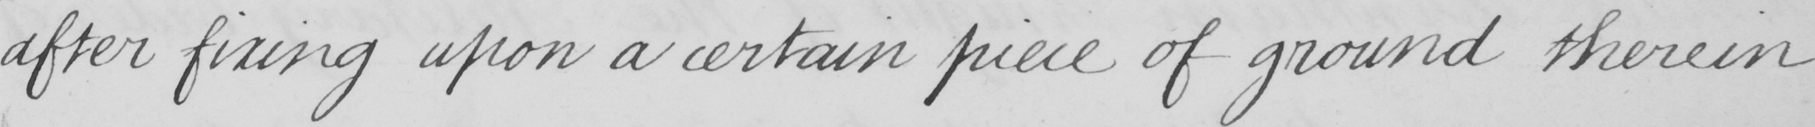Please provide the text content of this handwritten line. after fixing upon a certain piece of ground therein 